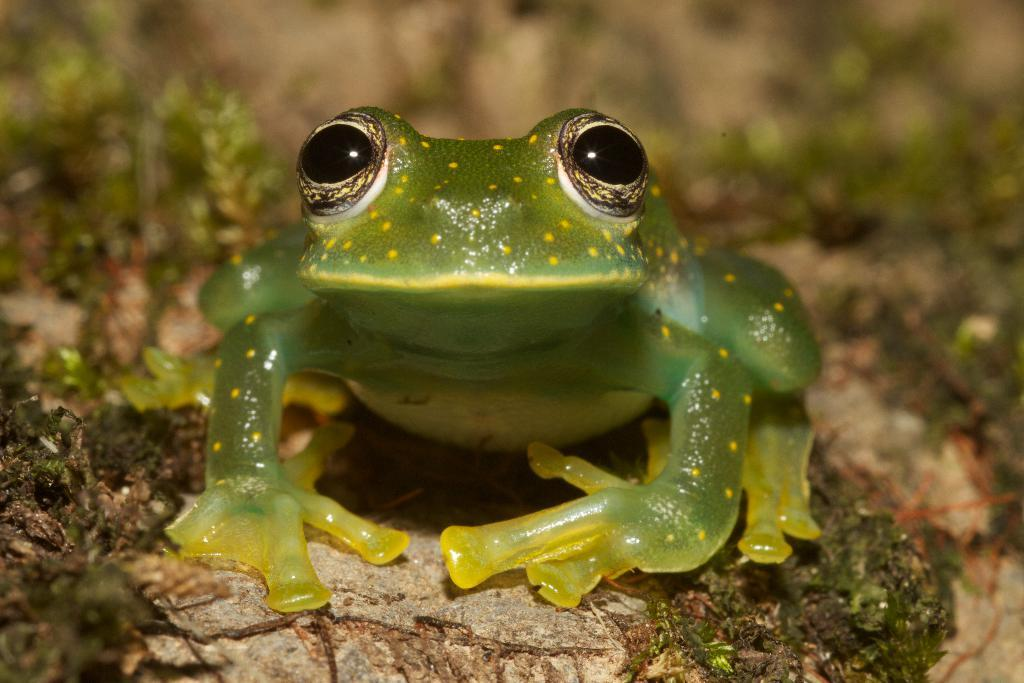What is the main subject of the image? There is a frog in the center of the image. What color is the frog? The frog is green in color. What can be seen in the background of the image? There are plants visible in the background of the image. How many bubbles are surrounding the frog in the image? There are no bubbles present in the image; it features a frog and plants in the background. 